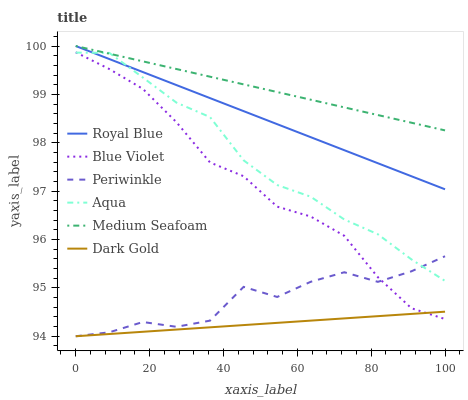Does Dark Gold have the minimum area under the curve?
Answer yes or no. Yes. Does Medium Seafoam have the maximum area under the curve?
Answer yes or no. Yes. Does Aqua have the minimum area under the curve?
Answer yes or no. No. Does Aqua have the maximum area under the curve?
Answer yes or no. No. Is Royal Blue the smoothest?
Answer yes or no. Yes. Is Periwinkle the roughest?
Answer yes or no. Yes. Is Aqua the smoothest?
Answer yes or no. No. Is Aqua the roughest?
Answer yes or no. No. Does Dark Gold have the lowest value?
Answer yes or no. Yes. Does Aqua have the lowest value?
Answer yes or no. No. Does Medium Seafoam have the highest value?
Answer yes or no. Yes. Does Aqua have the highest value?
Answer yes or no. No. Is Periwinkle less than Medium Seafoam?
Answer yes or no. Yes. Is Medium Seafoam greater than Periwinkle?
Answer yes or no. Yes. Does Blue Violet intersect Periwinkle?
Answer yes or no. Yes. Is Blue Violet less than Periwinkle?
Answer yes or no. No. Is Blue Violet greater than Periwinkle?
Answer yes or no. No. Does Periwinkle intersect Medium Seafoam?
Answer yes or no. No. 